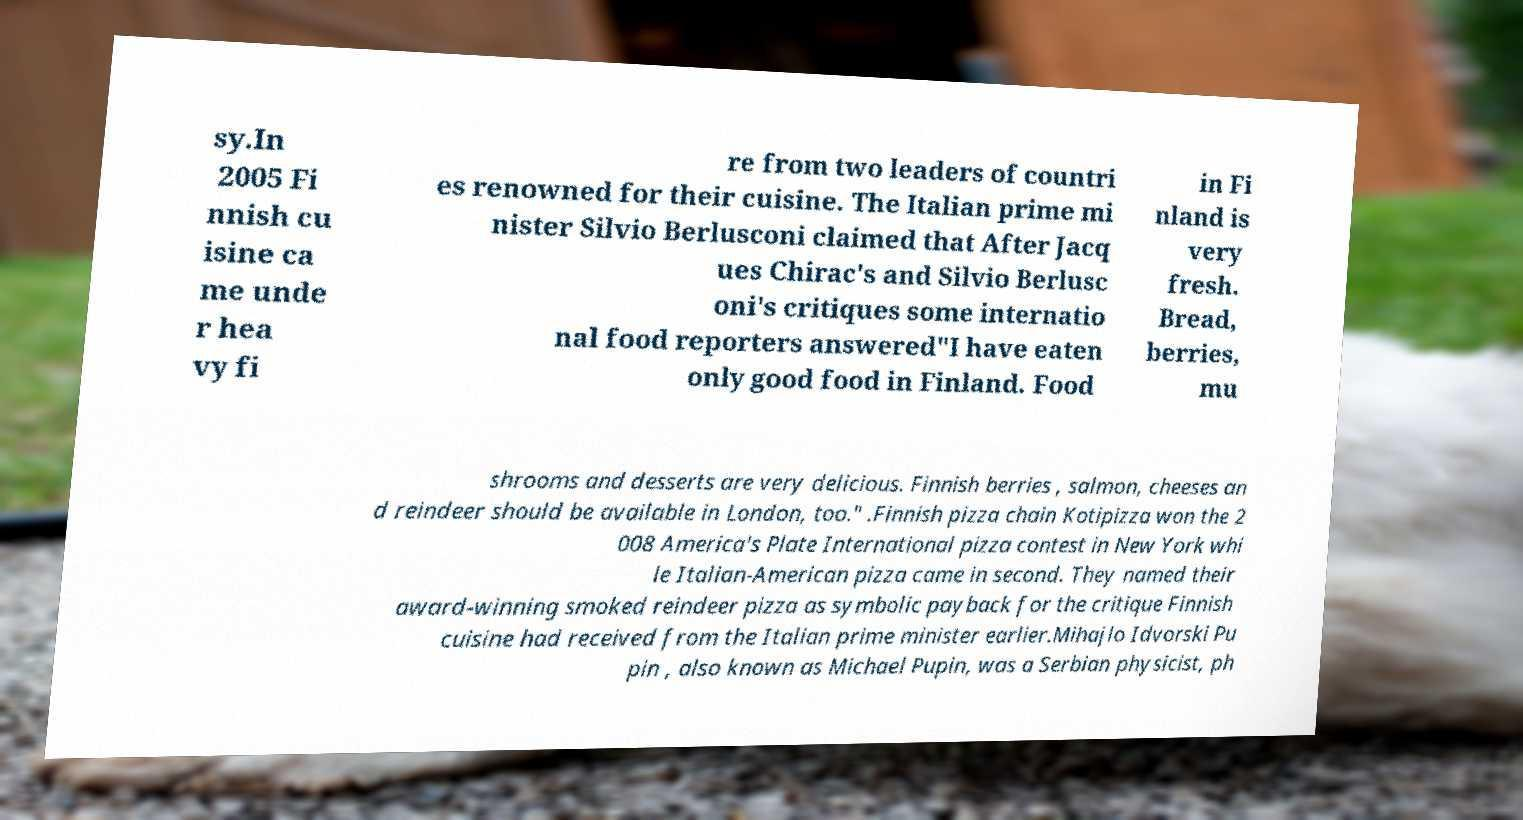For documentation purposes, I need the text within this image transcribed. Could you provide that? sy.In 2005 Fi nnish cu isine ca me unde r hea vy fi re from two leaders of countri es renowned for their cuisine. The Italian prime mi nister Silvio Berlusconi claimed that After Jacq ues Chirac's and Silvio Berlusc oni's critiques some internatio nal food reporters answered"I have eaten only good food in Finland. Food in Fi nland is very fresh. Bread, berries, mu shrooms and desserts are very delicious. Finnish berries , salmon, cheeses an d reindeer should be available in London, too." .Finnish pizza chain Kotipizza won the 2 008 America's Plate International pizza contest in New York whi le Italian-American pizza came in second. They named their award-winning smoked reindeer pizza as symbolic payback for the critique Finnish cuisine had received from the Italian prime minister earlier.Mihajlo Idvorski Pu pin , also known as Michael Pupin, was a Serbian physicist, ph 